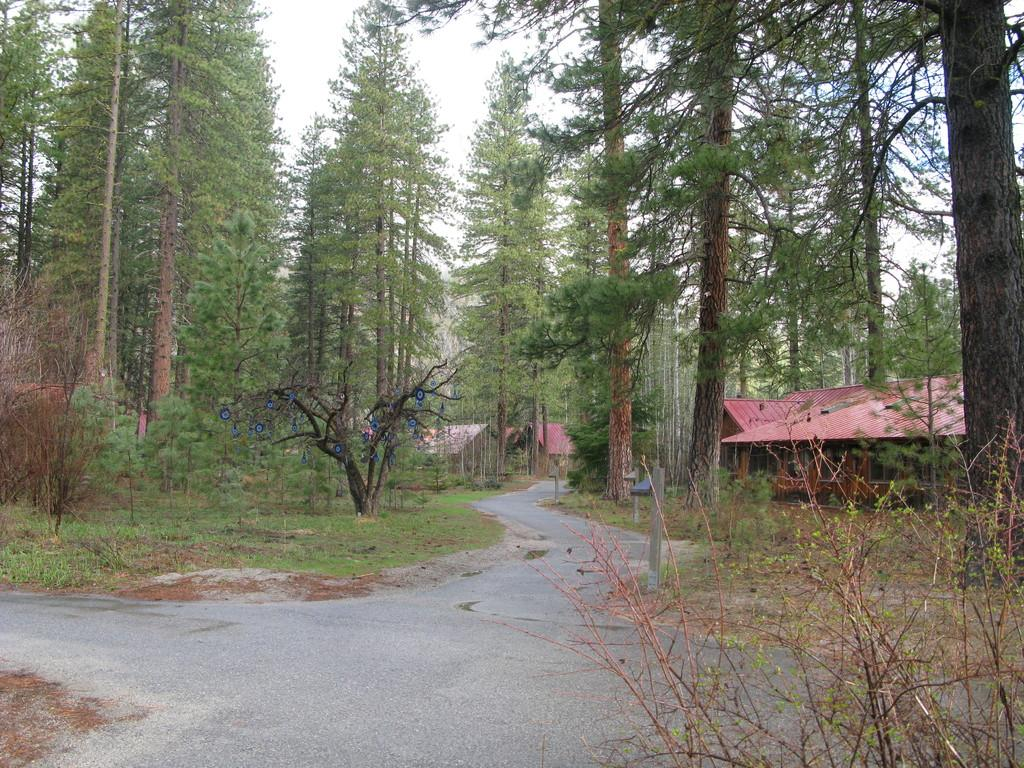What is the main feature of the image? There is a road in the image. What else can be seen in the image besides the road? There are many trees and houses on the right side of the image. What is visible at the top of the image? The sky is visible at the top of the image. How many eggs are present in the image? There are no eggs present in the image. What type of cake can be seen in the image? There is no cake present in the image. 